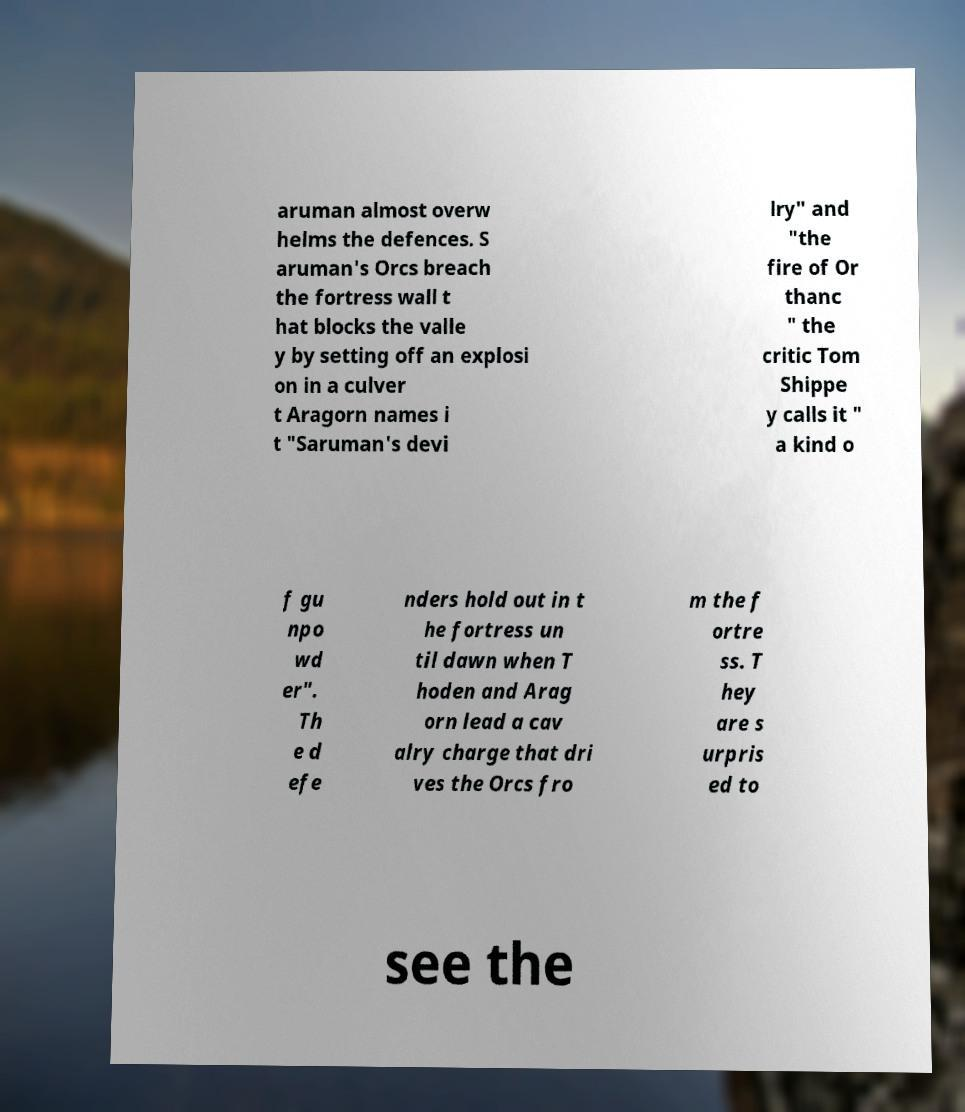Could you assist in decoding the text presented in this image and type it out clearly? aruman almost overw helms the defences. S aruman's Orcs breach the fortress wall t hat blocks the valle y by setting off an explosi on in a culver t Aragorn names i t "Saruman's devi lry" and "the fire of Or thanc " the critic Tom Shippe y calls it " a kind o f gu npo wd er". Th e d efe nders hold out in t he fortress un til dawn when T hoden and Arag orn lead a cav alry charge that dri ves the Orcs fro m the f ortre ss. T hey are s urpris ed to see the 